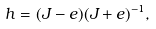Convert formula to latex. <formula><loc_0><loc_0><loc_500><loc_500>h = ( J - e ) ( J + e ) ^ { - 1 } ,</formula> 